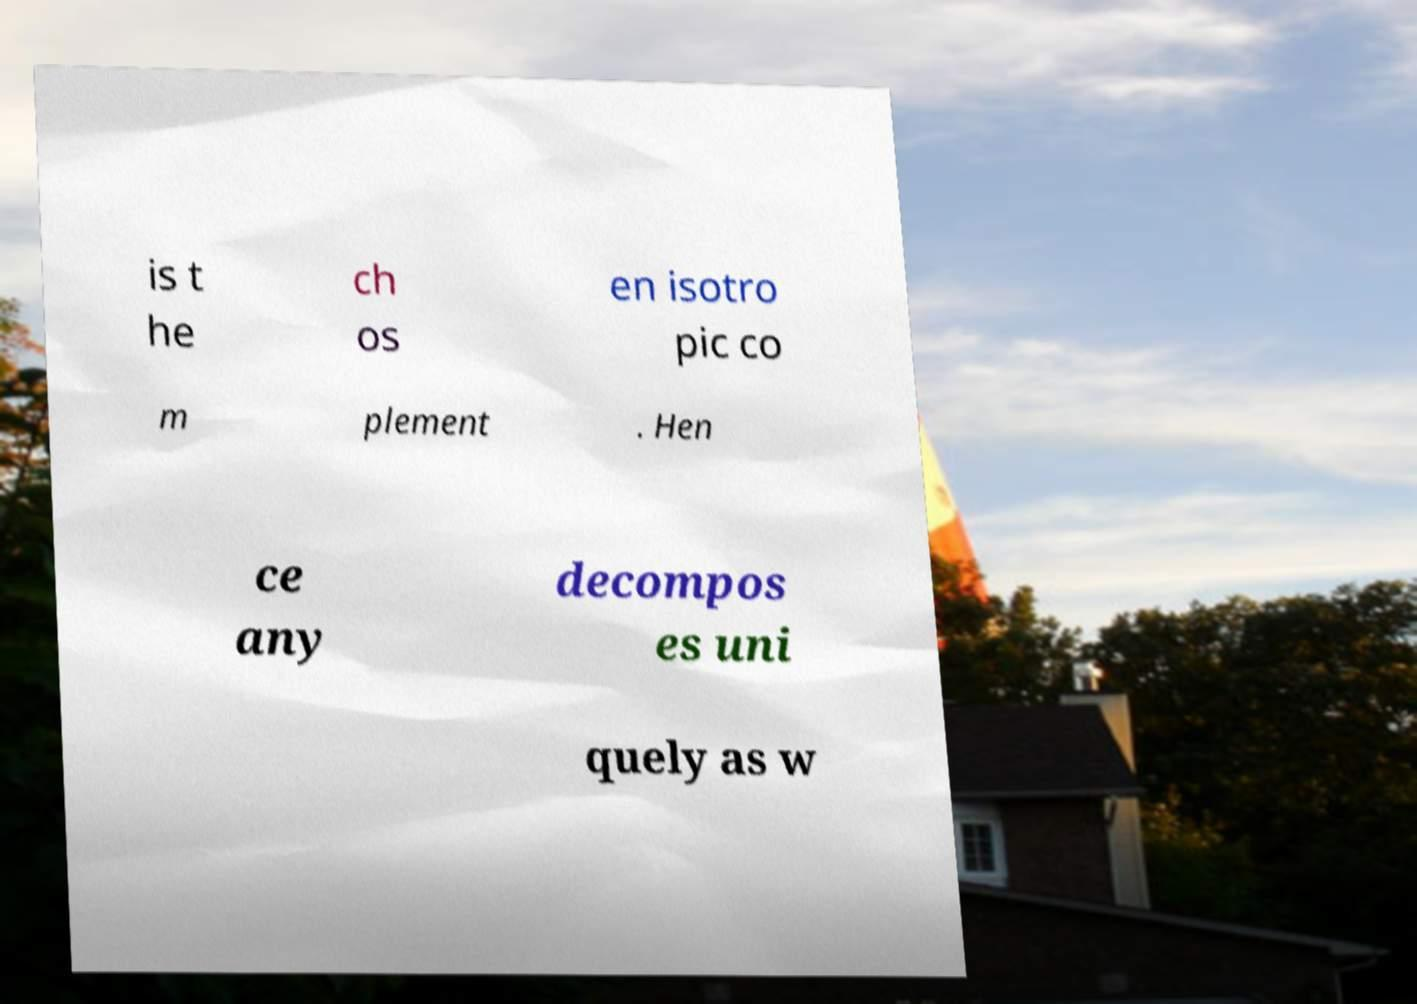What messages or text are displayed in this image? I need them in a readable, typed format. is t he ch os en isotro pic co m plement . Hen ce any decompos es uni quely as w 